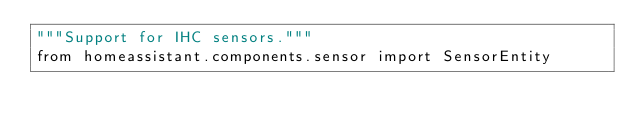<code> <loc_0><loc_0><loc_500><loc_500><_Python_>"""Support for IHC sensors."""
from homeassistant.components.sensor import SensorEntity</code> 